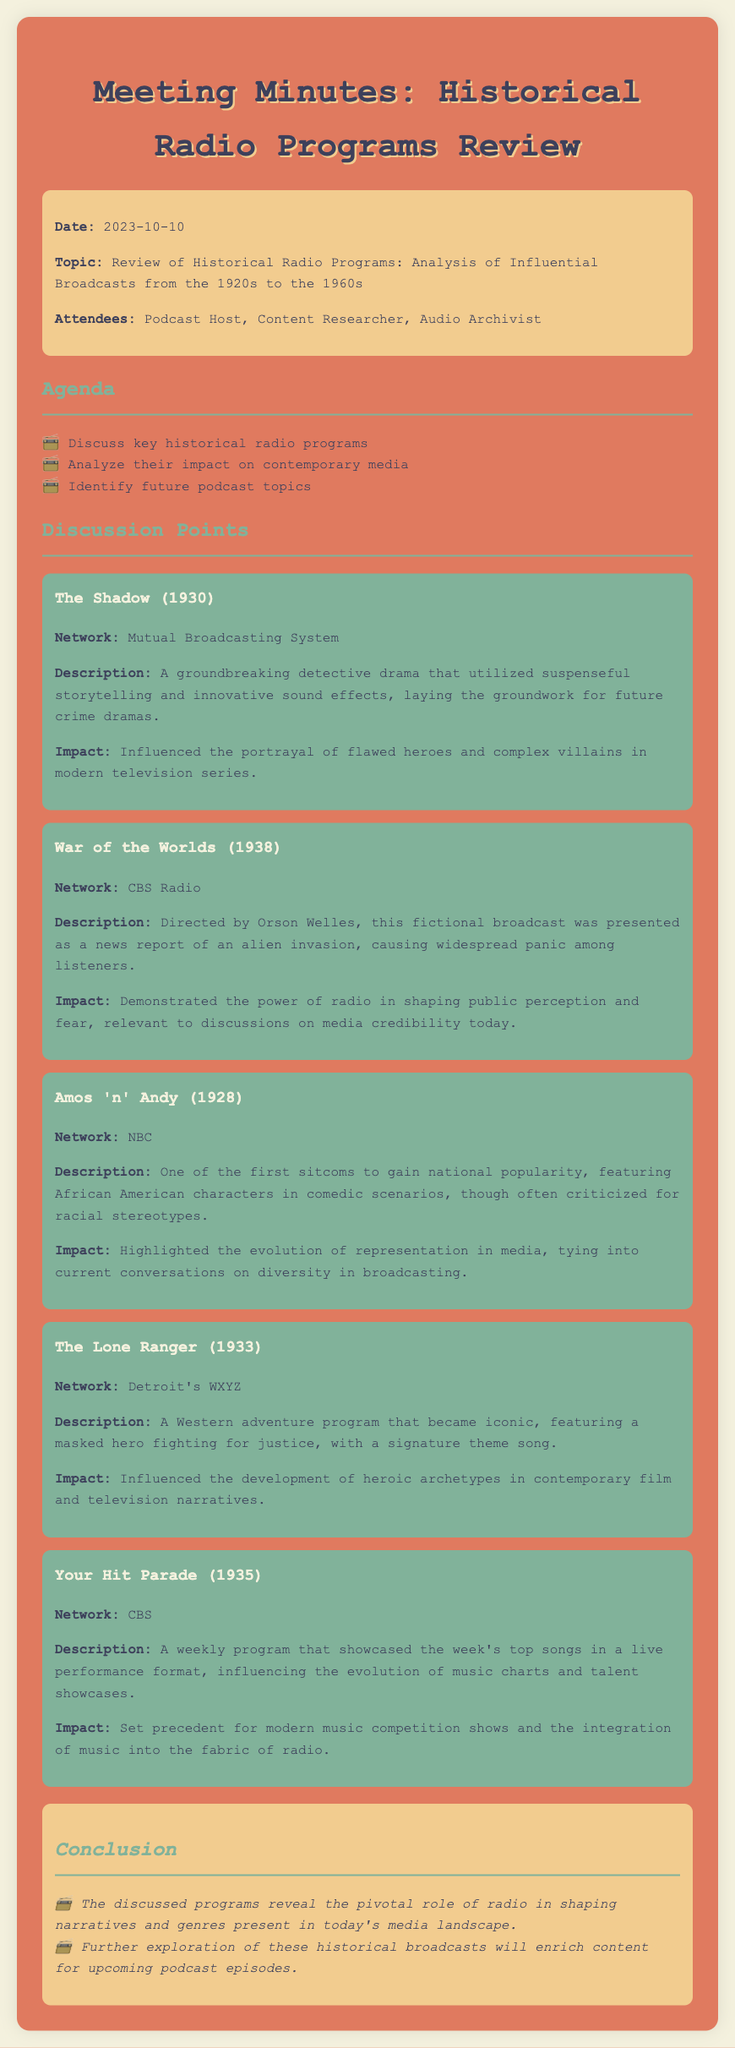what was the date of the meeting? The date is specified in the information section of the document.
Answer: 2023-10-10 who directed the "War of the Worlds" broadcast? The document names the individual who directed this influential broadcast.
Answer: Orson Welles which program was one of the first sitcoms to gain national popularity? This program is highlighted in the discussion points section for its significance in television history.
Answer: Amos 'n' Andy what was the impact of "Your Hit Parade"? The impact indicates how this program influenced modern forms of entertainment.
Answer: Set precedent for modern music competition shows which network aired "The Shadow"? The network is listed directly under the program description in the meeting minutes.
Answer: Mutual Broadcasting System what was a key theme of "The Lone Ranger"? This highlights a defining characteristic of the program that contributes to its legacy.
Answer: Fighting for justice how many historical radio programs were discussed? The total number of programs can be inferred from the document.
Answer: Five what is one primary conclusion from the meeting? This summarizes the overall findings and reflections on the discussed programs.
Answer: Pivotal role of radio in shaping narratives 